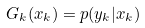Convert formula to latex. <formula><loc_0><loc_0><loc_500><loc_500>G _ { k } ( x _ { k } ) = p ( y _ { k } | x _ { k } )</formula> 